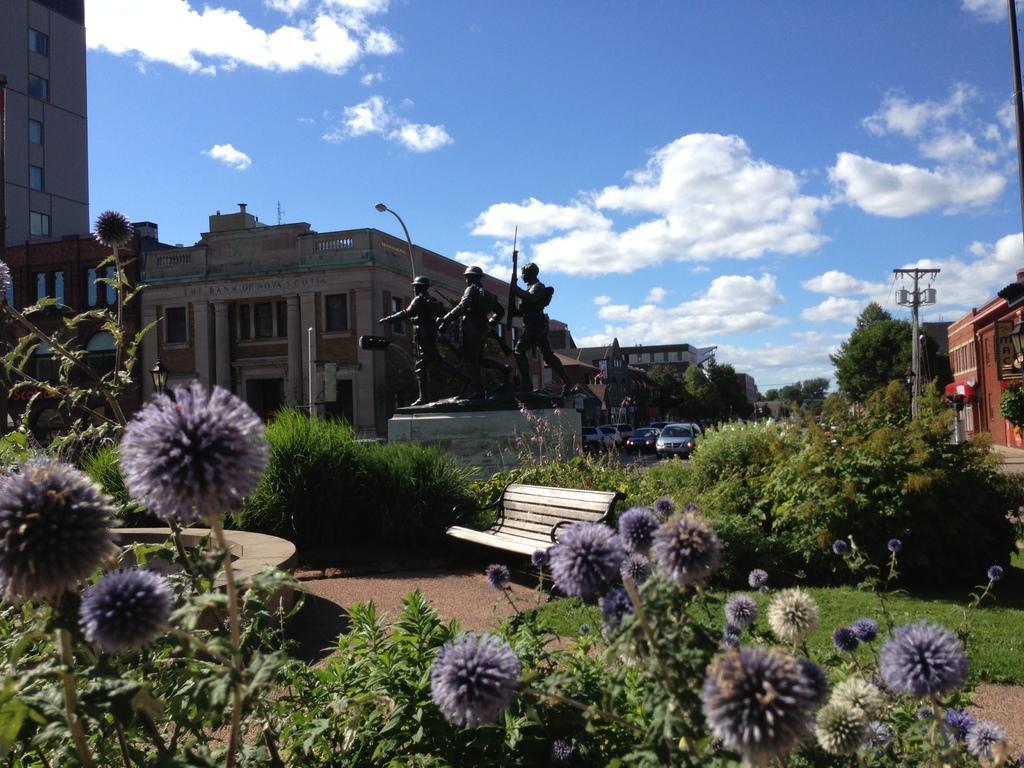Can you describe this image briefly? This image is taken outdoors, At the top of the image there is the sky with clouds. At the bottom of the image there are a few plants with leaves, stems and flowers. In the background there are a few buildings and houses with walls, windows, doors and roofs. There are a few trees. There are a few poles with street lights. A few cars are parked on the road. In the middle of the image there are three statues of men on the cornerstone. There are a few plants on the ground. There is an empty bench and there is a ground with grass on it. 